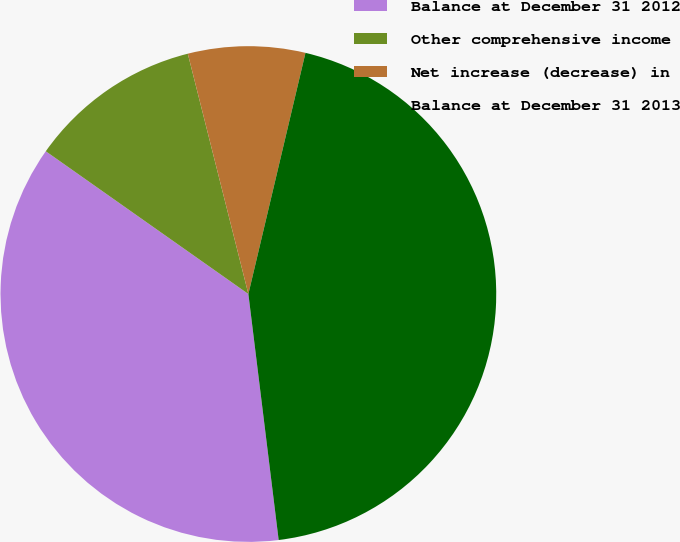<chart> <loc_0><loc_0><loc_500><loc_500><pie_chart><fcel>Balance at December 31 2012<fcel>Other comprehensive income<fcel>Net increase (decrease) in<fcel>Balance at December 31 2013<nl><fcel>36.72%<fcel>11.3%<fcel>7.63%<fcel>44.35%<nl></chart> 